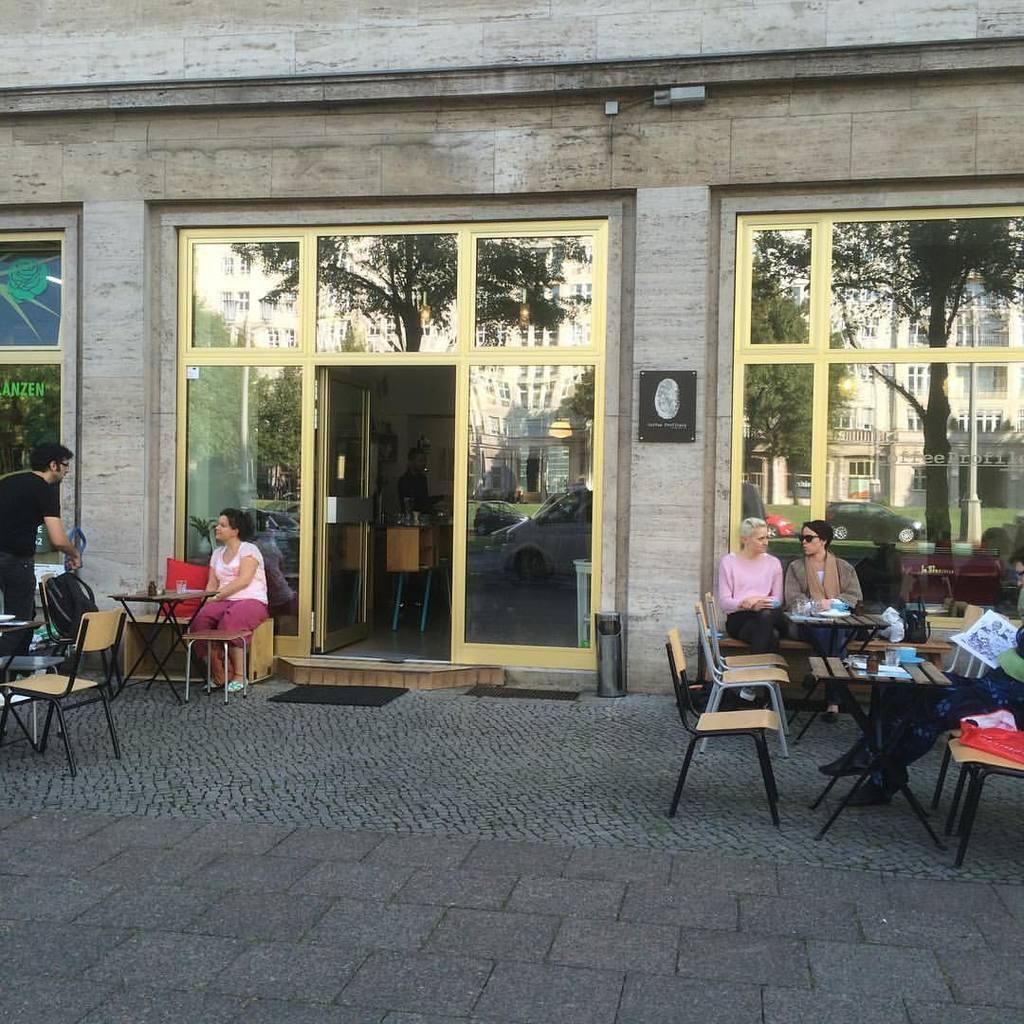In one or two sentences, can you explain what this image depicts? In this image, There is a floor in gray color, And there are some chairs in yellow color, And there are some people sitting on the chairs and in the background there are glass of windows in yellow color and there is a wall in cream color. 